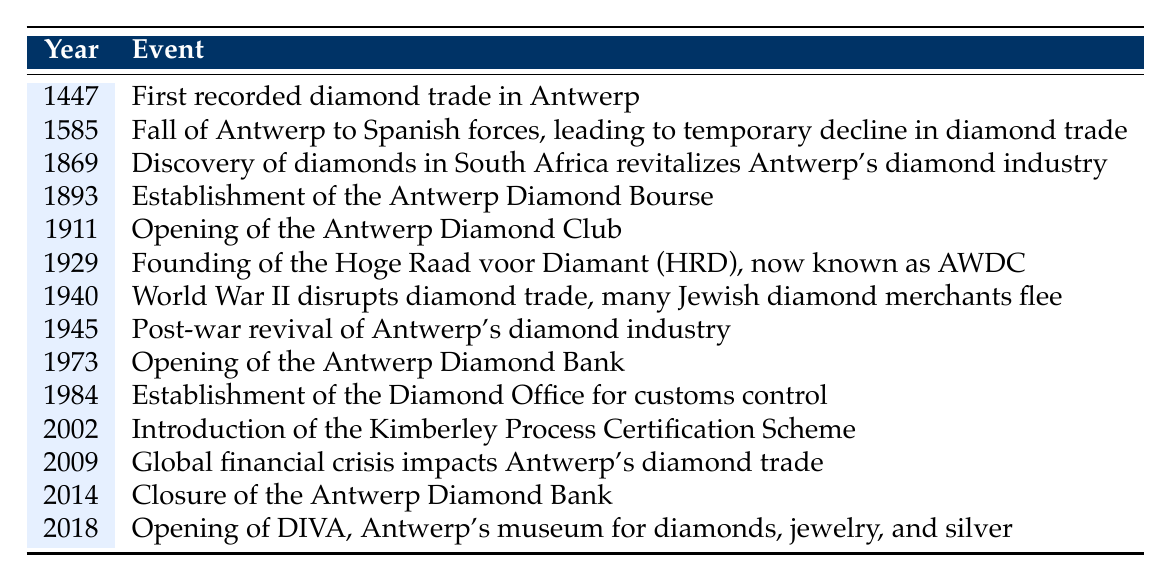What year did the first recorded diamond trade in Antwerp take place? The table indicates the event for the year 1447, which is noted as the first recorded diamond trade in Antwerp.
Answer: 1447 Which significant event occurred in 1911? According to the table, the event listed for 1911 is the opening of the Antwerp Diamond Club.
Answer: Opening of the Antwerp Diamond Club Was there a significant decline in diamond trade during the Spanish conquest of Antwerp? The table states that in 1585, the fall of Antwerp to Spanish forces led to a temporary decline in diamond trade, indicating that this statement is true.
Answer: Yes What are the two events related to the diamond trade that occurred in 1940 and 1945? In 1940, the table shows that World War II disrupted the diamond trade and many Jewish diamond merchants fled, while in 1945, it indicates a post-war revival of Antwerp's diamond industry.
Answer: Disruption in 1940 and revival in 1945 How many years passed between the establishment of the Antwerp Diamond Bourse and the opening of the Antwerp Diamond Bank? The table marks the establishment of the Antwerp Diamond Bourse in 1893 and the opening of the Antwerp Diamond Bank in 1973. The difference between these years is 1973 - 1893 = 80 years.
Answer: 80 years What was the significant impact of South African diamond discoveries in 1869 on Antwerp's diamond industry? The table states that the discovery of diamonds in South Africa in 1869 revitalized Antwerp's diamond industry, indicating a positive effect.
Answer: Revitalized the industry Which event marked the establishment of a customs control office for diamonds, and when did it occur? The table shows the establishment of the Diamond Office for customs control in 1984, marking when this event occurred.
Answer: In 1984 What was the immediate effect of the global financial crisis on Antwerp's diamond trade? According to the table, in 2009, the global financial crisis impacted Antwerp's diamond trade, suggesting that there were negative effects during that time.
Answer: Negative effects on trade What significant development in diamond certification happened in 2002? The table indicates that in 2002, the Kimberley Process Certification Scheme was introduced, a significant development in diamond certification.
Answer: Introduction of the Kimberley Process Which events directly relate to the Jewish community in the history of Antwerp's diamond district? The table highlights two events: the disruption of diamond trade and the fleeing of many Jewish diamond merchants in 1940, and it focuses on their experiences related to these events.
Answer: 1940 events In which year did Antwerp's diamond district experience a revival after World War II? The table notes that a post-war revival of Antwerp's diamond industry took place in 1945.
Answer: 1945 